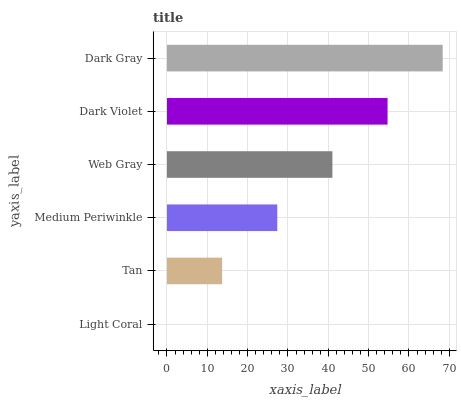Is Light Coral the minimum?
Answer yes or no. Yes. Is Dark Gray the maximum?
Answer yes or no. Yes. Is Tan the minimum?
Answer yes or no. No. Is Tan the maximum?
Answer yes or no. No. Is Tan greater than Light Coral?
Answer yes or no. Yes. Is Light Coral less than Tan?
Answer yes or no. Yes. Is Light Coral greater than Tan?
Answer yes or no. No. Is Tan less than Light Coral?
Answer yes or no. No. Is Web Gray the high median?
Answer yes or no. Yes. Is Medium Periwinkle the low median?
Answer yes or no. Yes. Is Tan the high median?
Answer yes or no. No. Is Tan the low median?
Answer yes or no. No. 